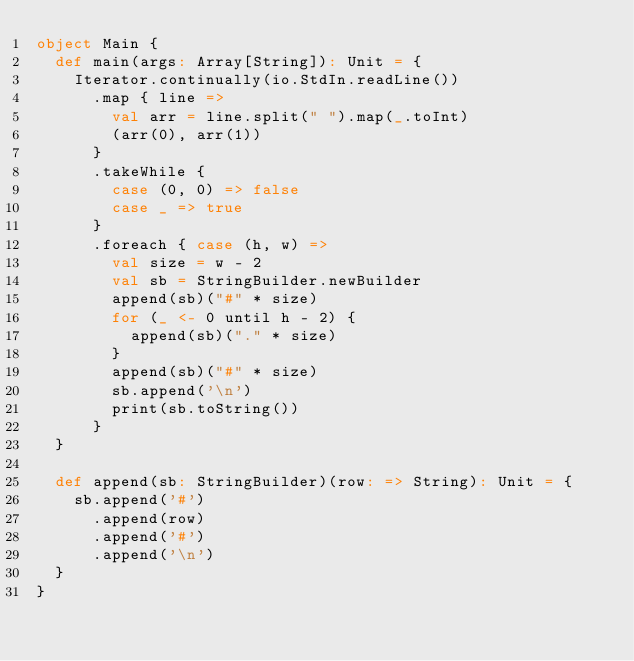<code> <loc_0><loc_0><loc_500><loc_500><_Scala_>object Main {
  def main(args: Array[String]): Unit = {
    Iterator.continually(io.StdIn.readLine())
      .map { line =>
        val arr = line.split(" ").map(_.toInt)
        (arr(0), arr(1))
      }
      .takeWhile {
        case (0, 0) => false
        case _ => true
      }
      .foreach { case (h, w) =>
        val size = w - 2
        val sb = StringBuilder.newBuilder
        append(sb)("#" * size)
        for (_ <- 0 until h - 2) {
          append(sb)("." * size)
        }
        append(sb)("#" * size)
        sb.append('\n')
        print(sb.toString())
      }
  }

  def append(sb: StringBuilder)(row: => String): Unit = {
    sb.append('#')
      .append(row)
      .append('#')
      .append('\n')
  }
}</code> 